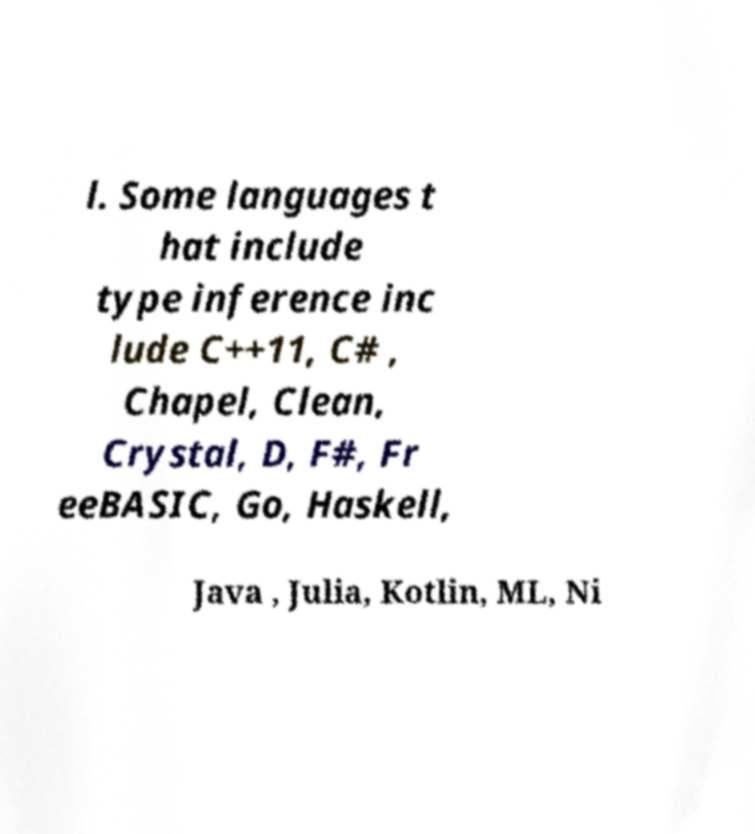Can you read and provide the text displayed in the image?This photo seems to have some interesting text. Can you extract and type it out for me? l. Some languages t hat include type inference inc lude C++11, C# , Chapel, Clean, Crystal, D, F#, Fr eeBASIC, Go, Haskell, Java , Julia, Kotlin, ML, Ni 